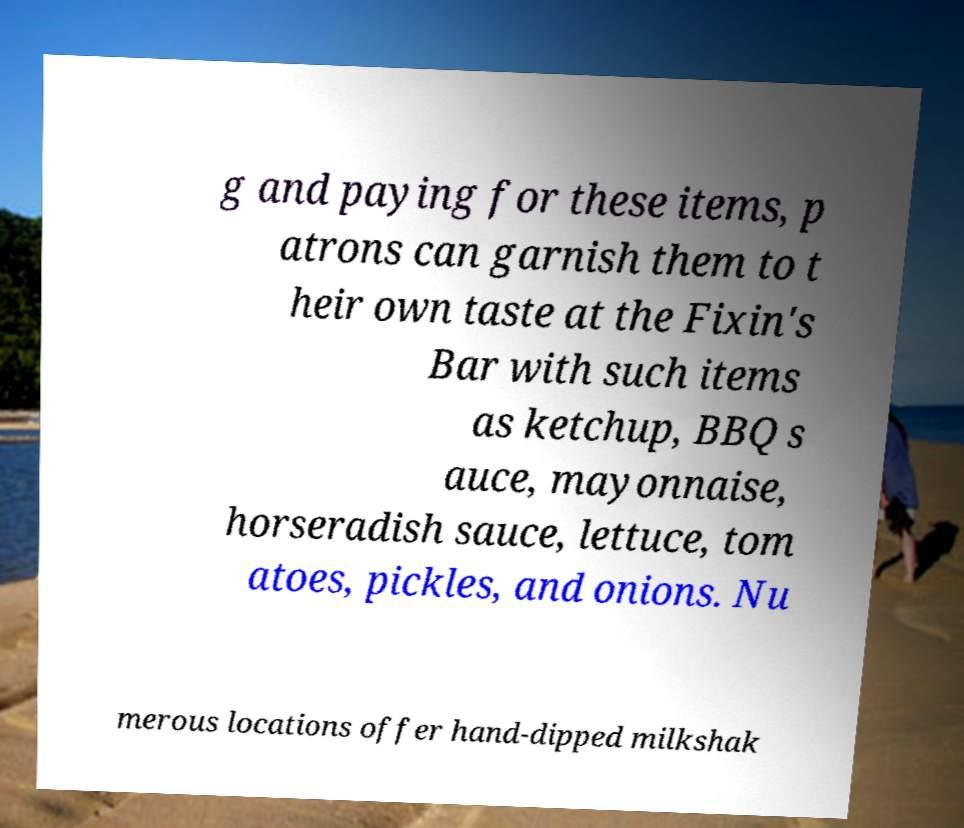Could you assist in decoding the text presented in this image and type it out clearly? g and paying for these items, p atrons can garnish them to t heir own taste at the Fixin's Bar with such items as ketchup, BBQ s auce, mayonnaise, horseradish sauce, lettuce, tom atoes, pickles, and onions. Nu merous locations offer hand-dipped milkshak 